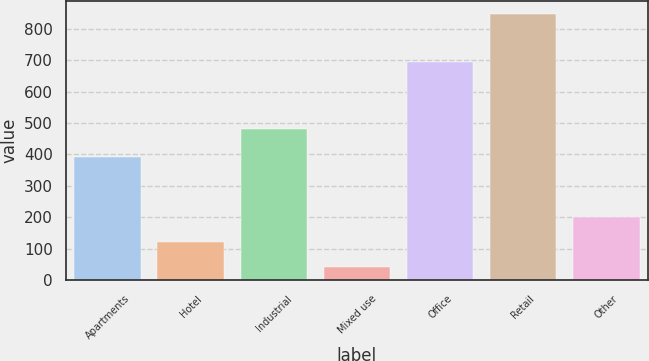Convert chart to OTSL. <chart><loc_0><loc_0><loc_500><loc_500><bar_chart><fcel>Apartments<fcel>Hotel<fcel>Industrial<fcel>Mixed use<fcel>Office<fcel>Retail<fcel>Other<nl><fcel>392<fcel>122.3<fcel>480<fcel>42<fcel>694<fcel>845<fcel>202.6<nl></chart> 